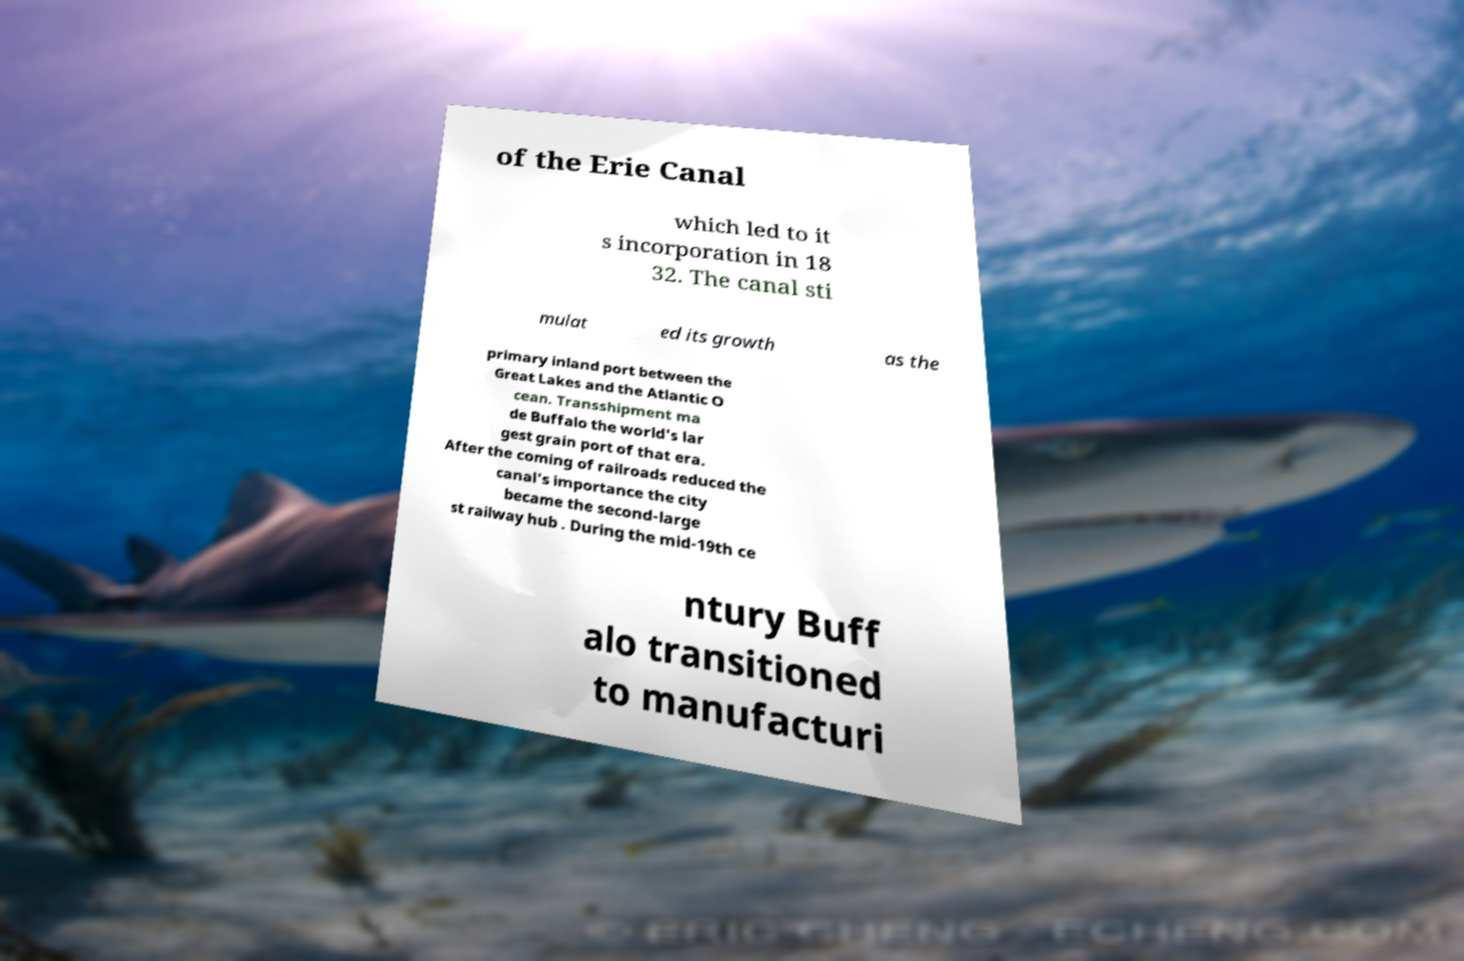Can you read and provide the text displayed in the image?This photo seems to have some interesting text. Can you extract and type it out for me? of the Erie Canal which led to it s incorporation in 18 32. The canal sti mulat ed its growth as the primary inland port between the Great Lakes and the Atlantic O cean. Transshipment ma de Buffalo the world's lar gest grain port of that era. After the coming of railroads reduced the canal's importance the city became the second-large st railway hub . During the mid-19th ce ntury Buff alo transitioned to manufacturi 